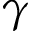Convert formula to latex. <formula><loc_0><loc_0><loc_500><loc_500>\gamma</formula> 